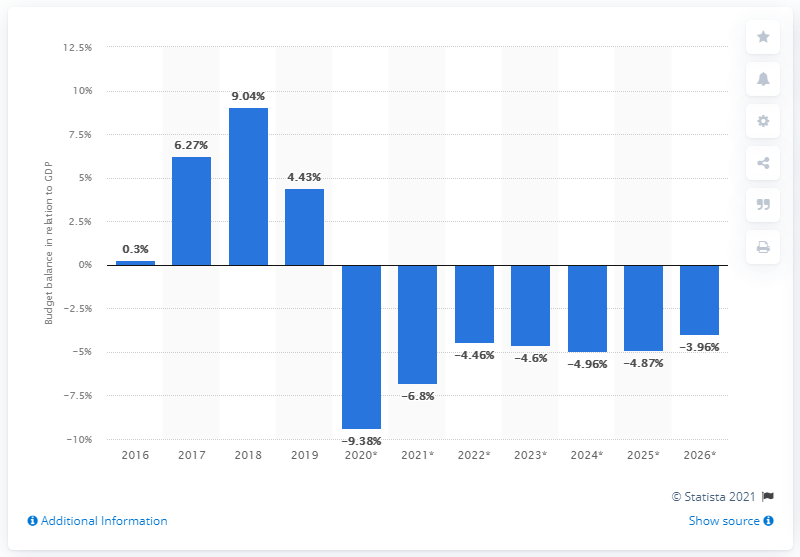Highlight a few significant elements in this photo. In 2019, Kuwait's budget surplus accounted for 4.43% of the country's Gross Domestic Product (GDP). 